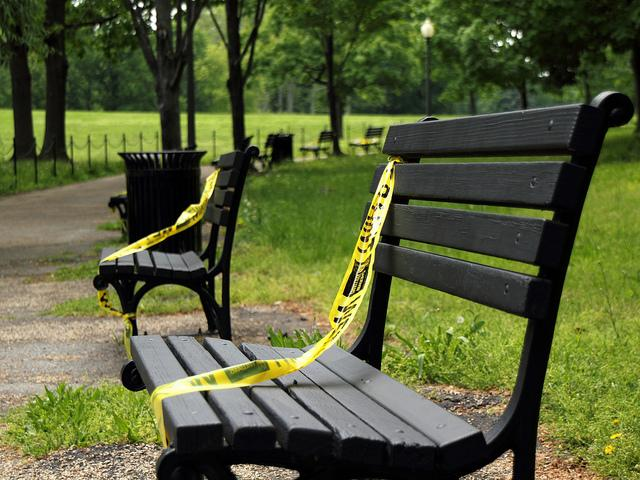For what reason were the benches likely sealed off with caution tape? Please explain your reasoning. wet paint. The park benches look too new to be used and look like they were just painted. 